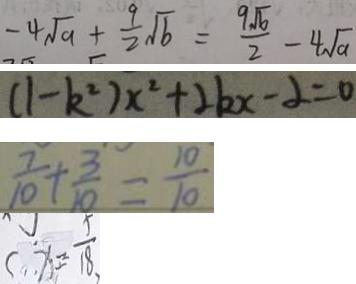<formula> <loc_0><loc_0><loc_500><loc_500>- 4 \sqrt { a } + \frac { 9 } { 2 } \sqrt { b } = \frac { 9 \sqrt { b } } { 2 } - 4 \sqrt { a } 
 ( 1 - k ^ { 2 } ) x ^ { 2 } + 2 k x - 2 = 0 
 \frac { 7 } { 1 0 } + \frac { 3 } { 1 0 } = \frac { 1 0 } { 1 0 } 
 x = \frac { 5 } { 1 8 }</formula> 